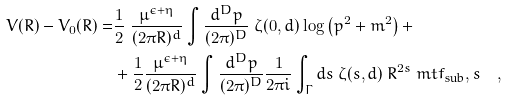<formula> <loc_0><loc_0><loc_500><loc_500>V ( R ) - V _ { 0 } ( R ) = & \frac { 1 } { 2 } \ \frac { \mu ^ { \epsilon + \eta } } { ( 2 \pi R ) ^ { d } } \int \frac { d ^ { D } p } { ( 2 \pi ) ^ { D } } \ \zeta ( 0 , d ) \log \left ( p ^ { 2 } + m ^ { 2 } \right ) + \\ & + \frac { 1 } { 2 } \frac { \mu ^ { \epsilon + \eta } } { ( 2 \pi R ) ^ { d } } \int \frac { d ^ { D } p } { ( 2 \pi ) ^ { D } } \frac { 1 } { 2 \pi i } \int _ { \Gamma } d s \ \zeta ( s , d ) \ R ^ { 2 s } \ m t { f _ { \text {sub} } , s } \quad ,</formula> 